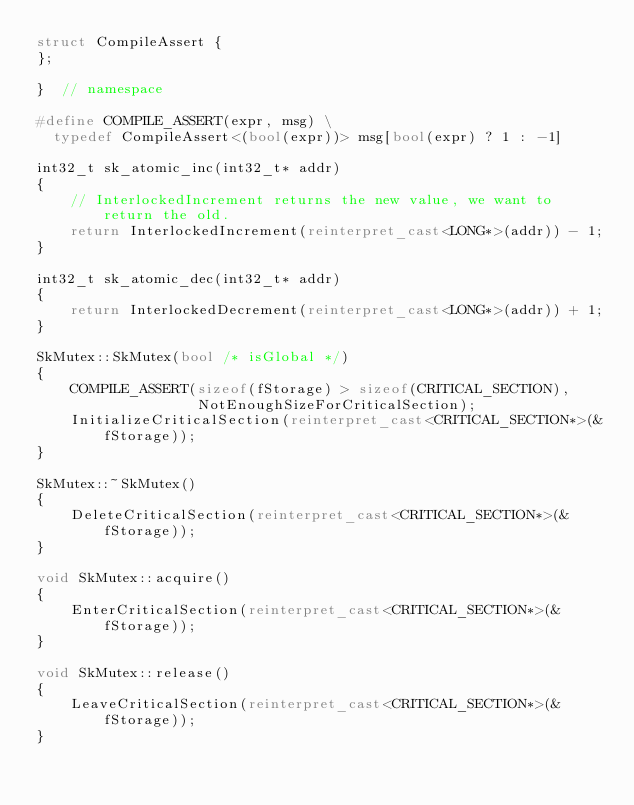Convert code to text. <code><loc_0><loc_0><loc_500><loc_500><_C++_>struct CompileAssert {
};

}  // namespace

#define COMPILE_ASSERT(expr, msg) \
  typedef CompileAssert<(bool(expr))> msg[bool(expr) ? 1 : -1]

int32_t sk_atomic_inc(int32_t* addr)
{
    // InterlockedIncrement returns the new value, we want to return the old.
    return InterlockedIncrement(reinterpret_cast<LONG*>(addr)) - 1;
}

int32_t sk_atomic_dec(int32_t* addr)
{
    return InterlockedDecrement(reinterpret_cast<LONG*>(addr)) + 1;
}

SkMutex::SkMutex(bool /* isGlobal */)
{
    COMPILE_ASSERT(sizeof(fStorage) > sizeof(CRITICAL_SECTION),
                   NotEnoughSizeForCriticalSection);
    InitializeCriticalSection(reinterpret_cast<CRITICAL_SECTION*>(&fStorage));
}

SkMutex::~SkMutex()
{
    DeleteCriticalSection(reinterpret_cast<CRITICAL_SECTION*>(&fStorage));
}

void SkMutex::acquire()
{
    EnterCriticalSection(reinterpret_cast<CRITICAL_SECTION*>(&fStorage));
}

void SkMutex::release()
{
    LeaveCriticalSection(reinterpret_cast<CRITICAL_SECTION*>(&fStorage));
}

</code> 